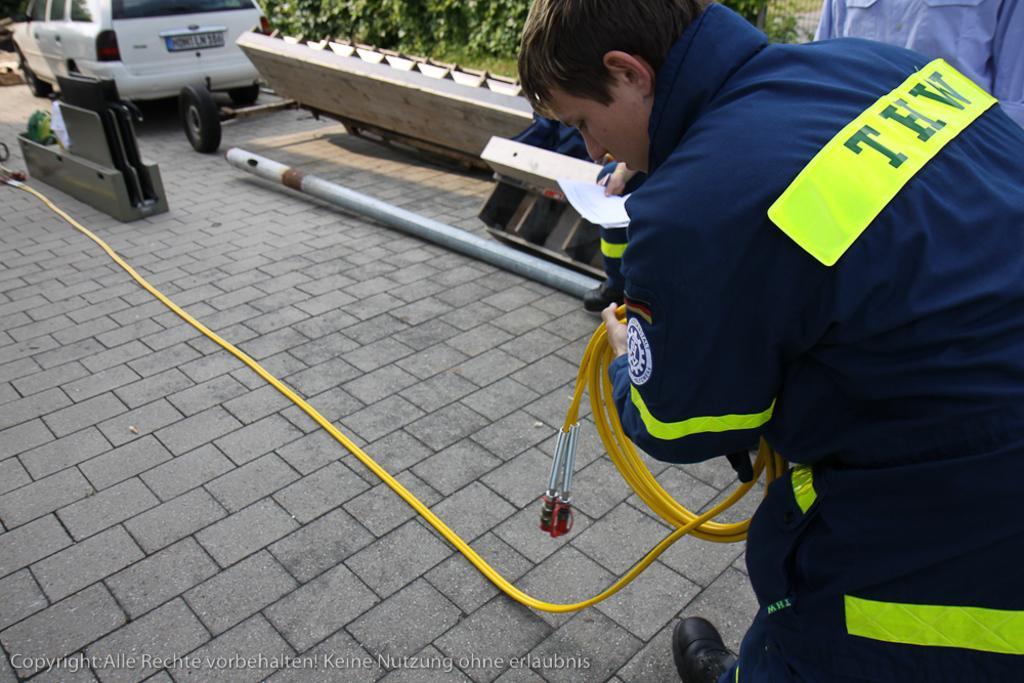Please provide a concise description of this image. In this image we can see three people, among them, two are holding the objects, there are plants, pole, vehicle and some other objects, at the bottom of the image we can see the text. 